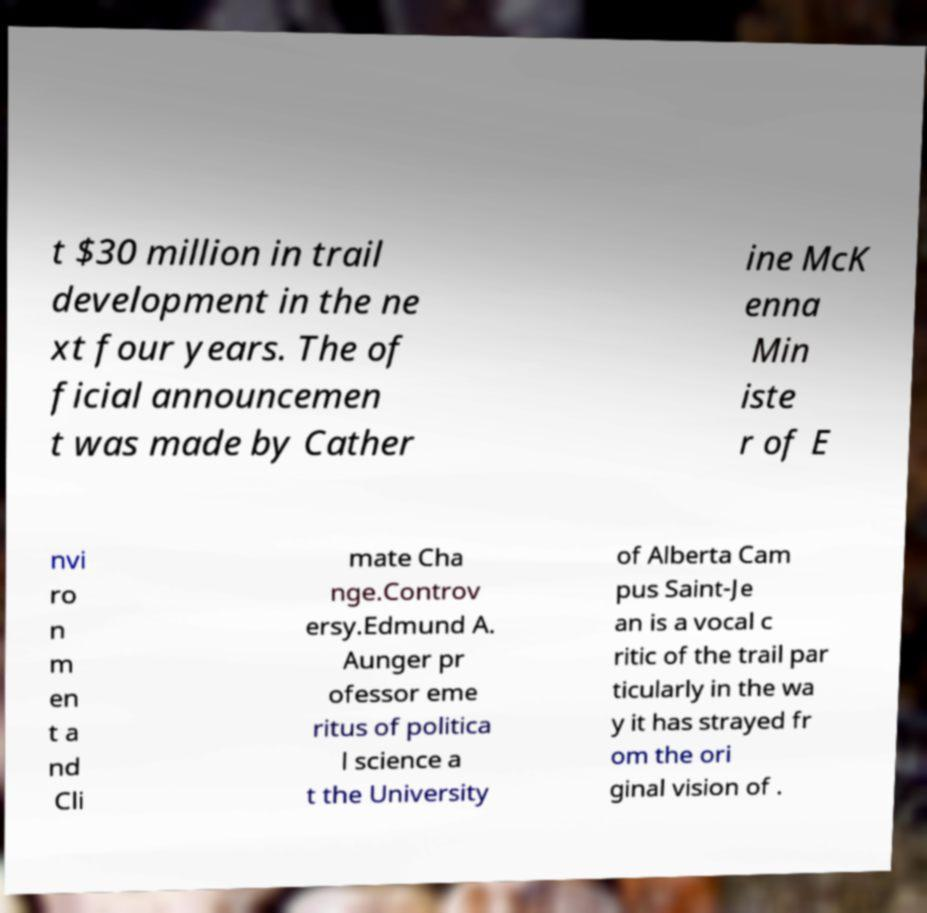Could you extract and type out the text from this image? t $30 million in trail development in the ne xt four years. The of ficial announcemen t was made by Cather ine McK enna Min iste r of E nvi ro n m en t a nd Cli mate Cha nge.Controv ersy.Edmund A. Aunger pr ofessor eme ritus of politica l science a t the University of Alberta Cam pus Saint-Je an is a vocal c ritic of the trail par ticularly in the wa y it has strayed fr om the ori ginal vision of . 